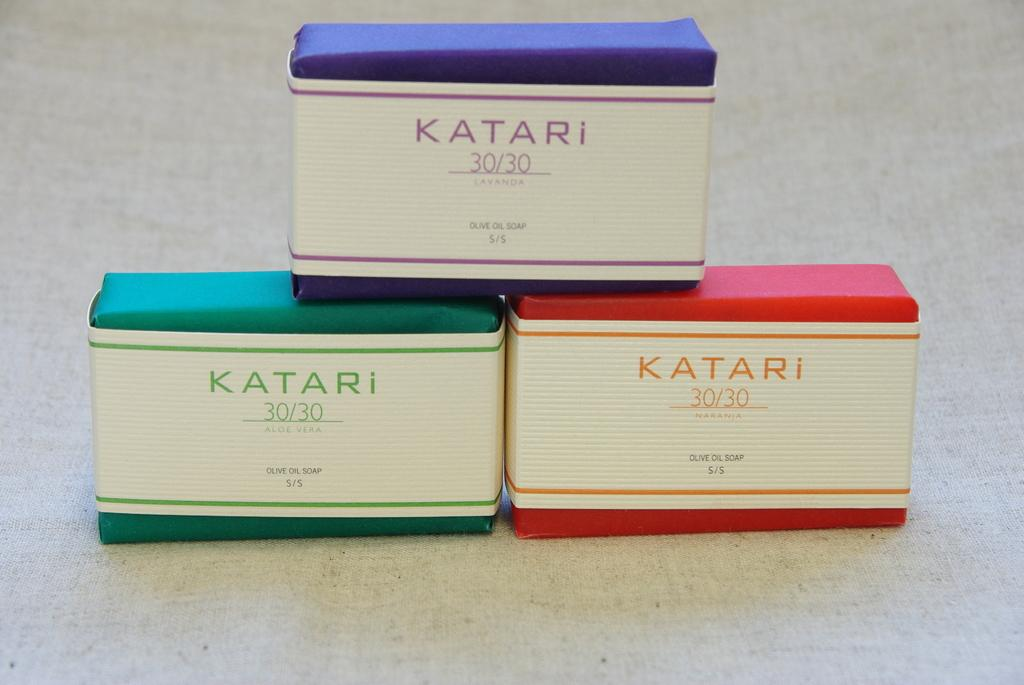<image>
Create a compact narrative representing the image presented. three colorful bars of Katari 30/30 olive oil soap 